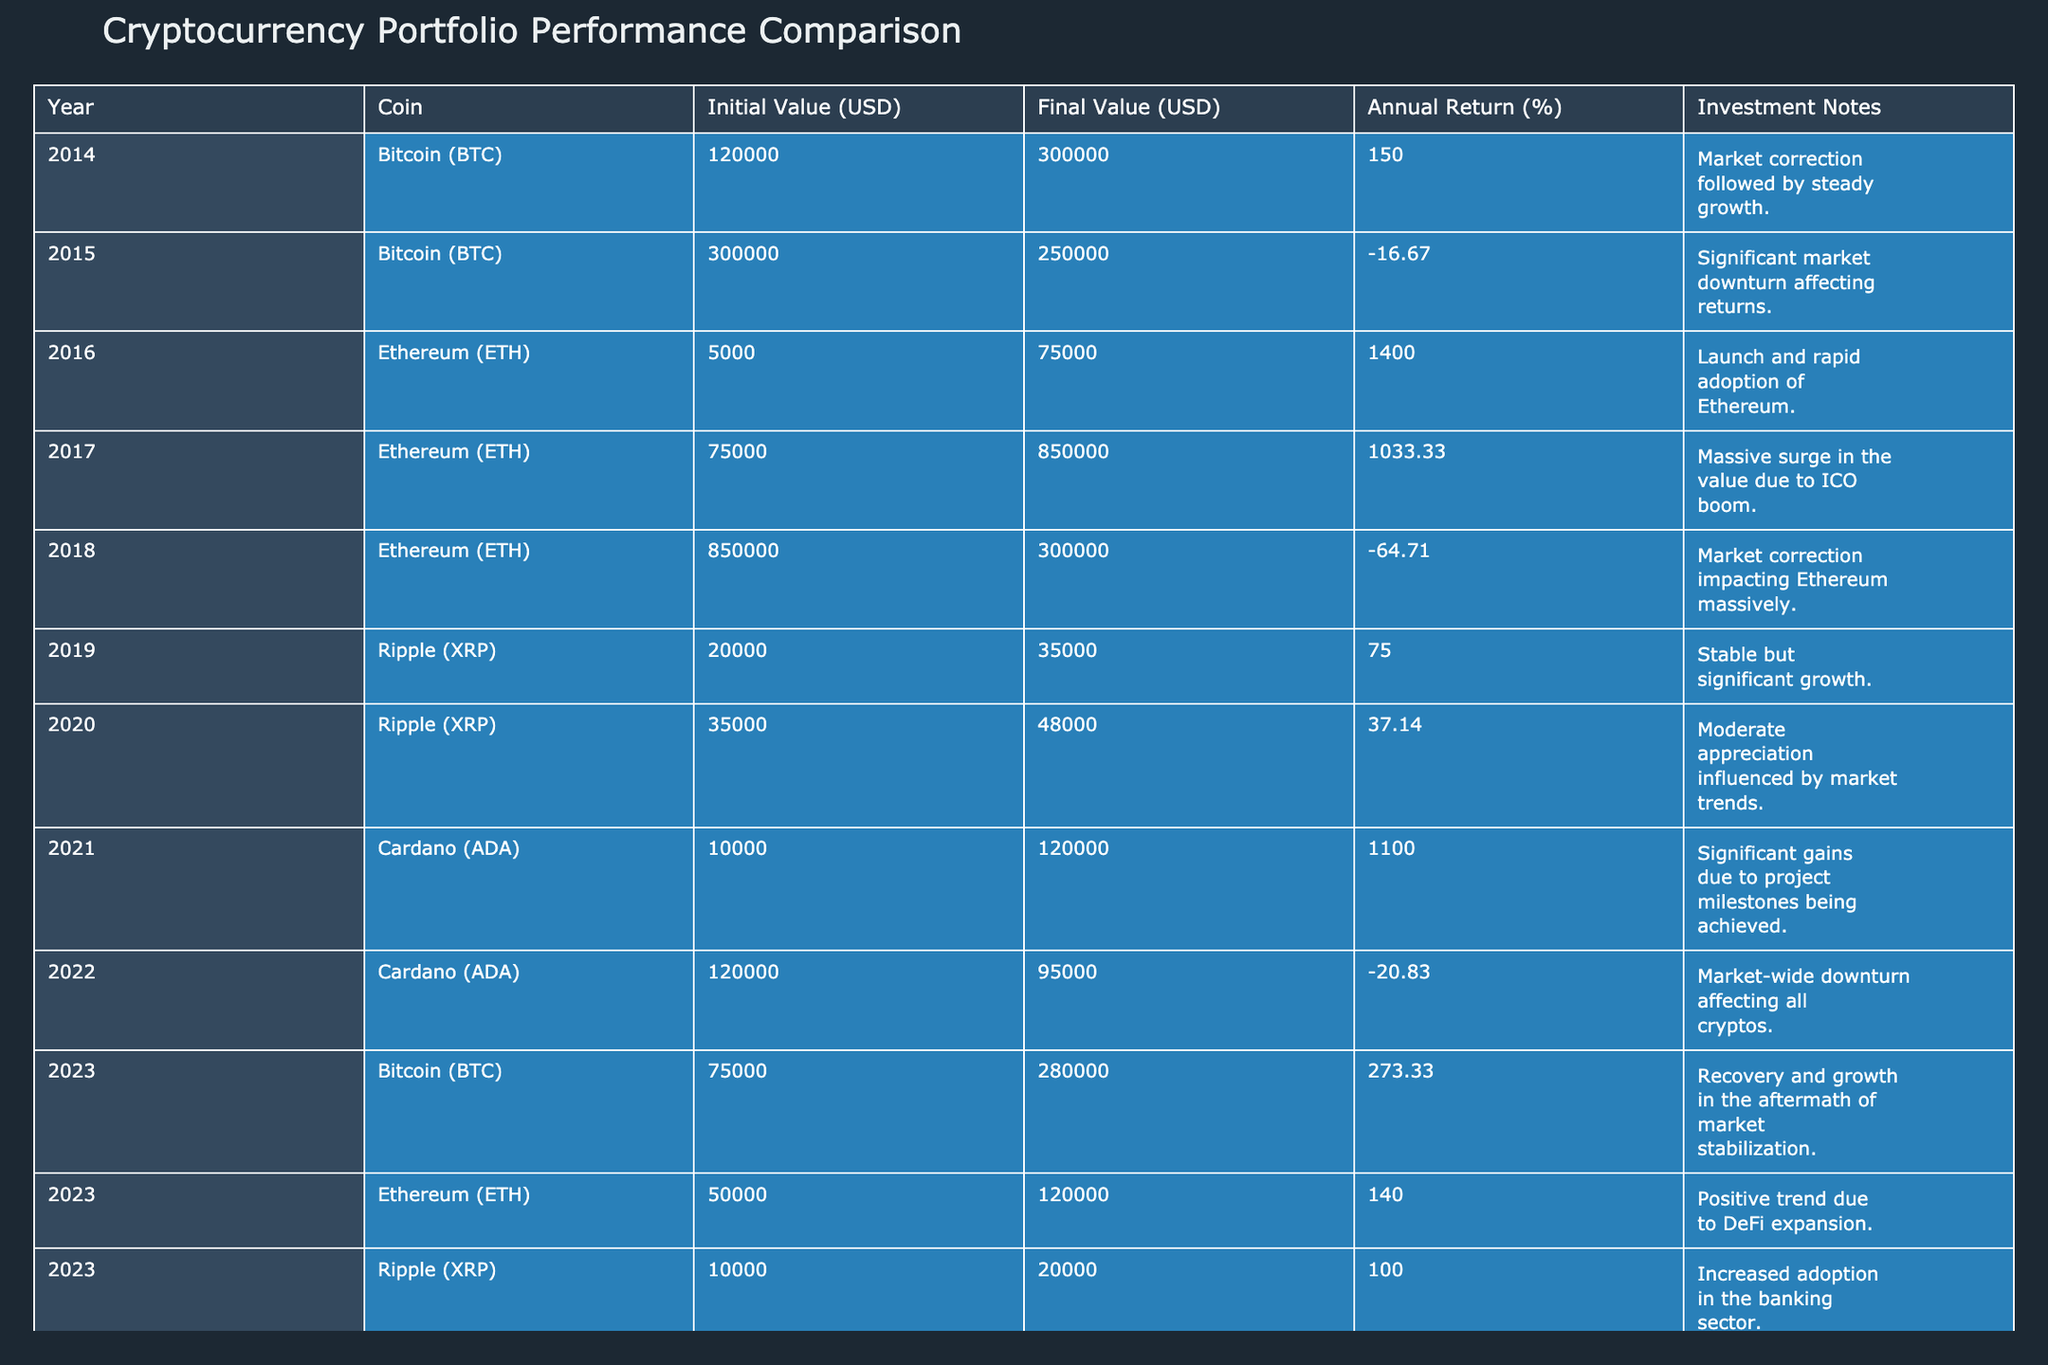What was the initial value of Bitcoin in 2014? The table indicates that the initial value of Bitcoin in 2014 was 120000 USD.
Answer: 120000 USD Which year had the highest annual return for Cardano? In the table, Cardano's highest annual return was 1100% in 2021.
Answer: 2021 What is the average final value of Ethereum across the years listed? The final values of Ethereum are 75000, 850000, 300000, and 120000. Summing these gives 75000 + 850000 + 300000 + 120000 = 1350000. Dividing by 4 (the number of years) gives an average of 337500.
Answer: 337500 USD Did Cardano experience a loss in value in 2022? The table shows that Cardano had a final value of 95000 USD in 2022, decreasing from its initial value of 120000 USD, indicating a loss of value.
Answer: Yes What was the difference in annual returns for Bitcoin from 2015 to 2023? In 2015, Bitcoin's annual return was -16.67%, and in 2023, it was 273.33%. The difference is 273.33 - (-16.67) = 290.00.
Answer: 290.00% Which coin had the worst annual return in 2018? The table reveals that Ethereum had an annual return of -64.71% in 2018, which is the lowest among the listed values for that year.
Answer: Ethereum What percentage of initial value did Ripple achieve in 2020 compared to 2019? In 2019, Ripple had a final value of 35000 USD from an initial value of 20000 USD. In 2020, Ripple's final value was 48000 USD from an initial value of 35000 USD. The percentage change from 2019 to 2020 is calculated as ((48000 - 35000) / 35000) * 100 = 37.14%.
Answer: 37.14% In which year did Ethereum have a negative annual return and by how much? The table records negative annual returns for Ethereum in 2018, with a decrease of -64.71%.
Answer: 2018, -64.71% What is the total investment value for Ripple from 2019 to 2023? The table lists Ripple with initial values of 20000 (2019), 35000 (2020), and 10000 (2023). Summing these gives 20000 + 35000 + 10000 = 65000 USD.
Answer: 65000 USD 